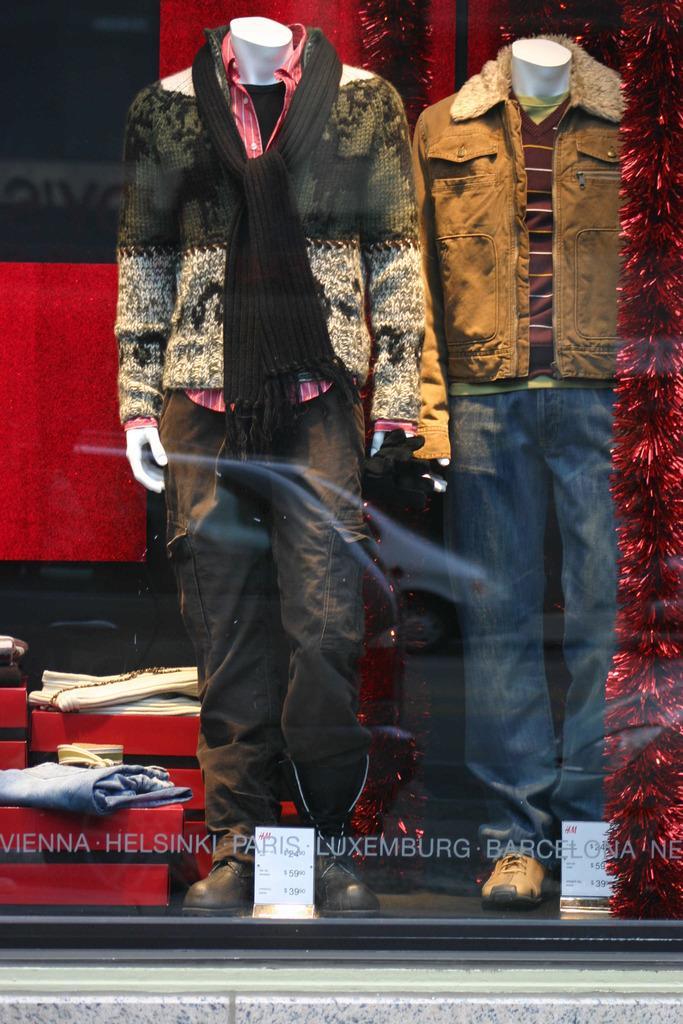Can you describe this image briefly? In the image we can see a glass window. Through the glass window we can see some mannequins, on the mannequins there are some clothes. 